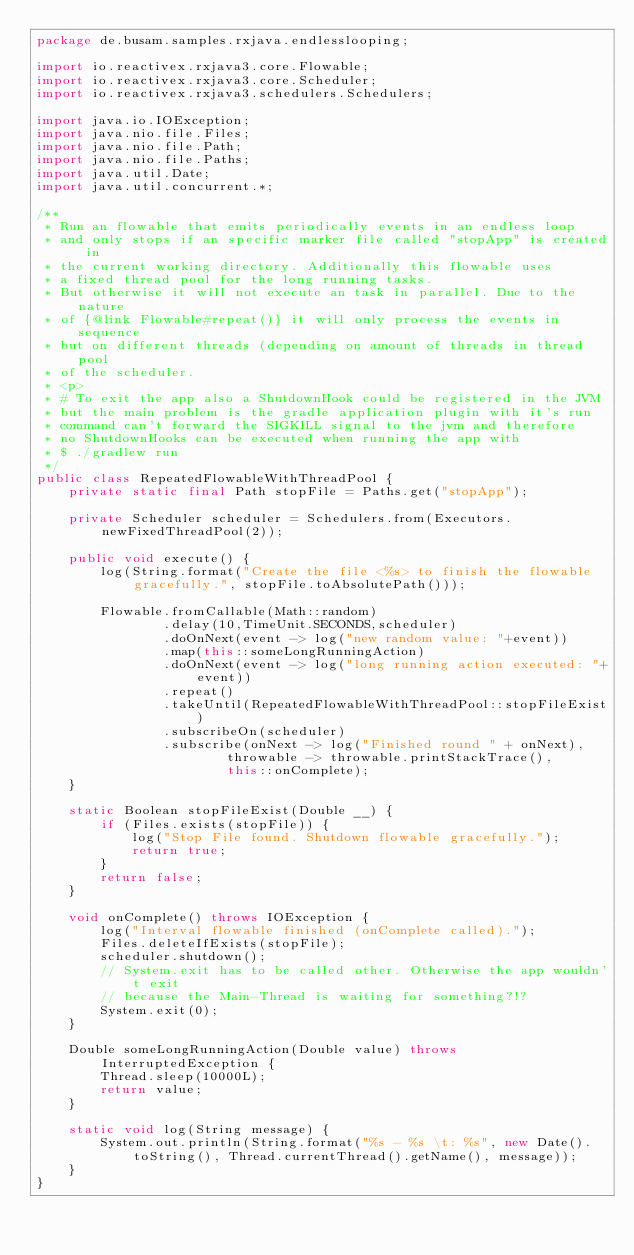Convert code to text. <code><loc_0><loc_0><loc_500><loc_500><_Java_>package de.busam.samples.rxjava.endlesslooping;

import io.reactivex.rxjava3.core.Flowable;
import io.reactivex.rxjava3.core.Scheduler;
import io.reactivex.rxjava3.schedulers.Schedulers;

import java.io.IOException;
import java.nio.file.Files;
import java.nio.file.Path;
import java.nio.file.Paths;
import java.util.Date;
import java.util.concurrent.*;

/**
 * Run an flowable that emits periodically events in an endless loop
 * and only stops if an specific marker file called "stopApp" is created in
 * the current working directory. Additionally this flowable uses
 * a fixed thread pool for the long running tasks.
 * But otherwise it will not execute an task in parallel. Due to the nature
 * of {@link Flowable#repeat()} it will only process the events in sequence
 * but on different threads (depending on amount of threads in thread pool
 * of the scheduler.
 * <p>
 * # To exit the app also a ShutdownHook could be registered in the JVM
 * but the main problem is the gradle application plugin with it's run
 * command can't forward the SIGKILL signal to the jvm and therefore
 * no ShutdownHooks can be executed when running the app with
 * $ ./gradlew run
 */
public class RepeatedFlowableWithThreadPool {
    private static final Path stopFile = Paths.get("stopApp");

    private Scheduler scheduler = Schedulers.from(Executors.newFixedThreadPool(2));

    public void execute() {
        log(String.format("Create the file <%s> to finish the flowable gracefully.", stopFile.toAbsolutePath()));

        Flowable.fromCallable(Math::random)
                .delay(10,TimeUnit.SECONDS,scheduler)
                .doOnNext(event -> log("new random value: "+event))
                .map(this::someLongRunningAction)
                .doOnNext(event -> log("long running action executed: "+event))
                .repeat()
                .takeUntil(RepeatedFlowableWithThreadPool::stopFileExist)
                .subscribeOn(scheduler)
                .subscribe(onNext -> log("Finished round " + onNext),
                        throwable -> throwable.printStackTrace(),
                        this::onComplete);
    }

    static Boolean stopFileExist(Double __) {
        if (Files.exists(stopFile)) {
            log("Stop File found. Shutdown flowable gracefully.");
            return true;
        }
        return false;
    }

    void onComplete() throws IOException {
        log("Interval flowable finished (onComplete called).");
        Files.deleteIfExists(stopFile);
        scheduler.shutdown();
        // System.exit has to be called other. Otherwise the app wouldn't exit
        // because the Main-Thread is waiting for something?!?
        System.exit(0);
    }

    Double someLongRunningAction(Double value) throws InterruptedException {
        Thread.sleep(10000L);
        return value;
    }

    static void log(String message) {
        System.out.println(String.format("%s - %s \t: %s", new Date().toString(), Thread.currentThread().getName(), message));
    }
}
</code> 